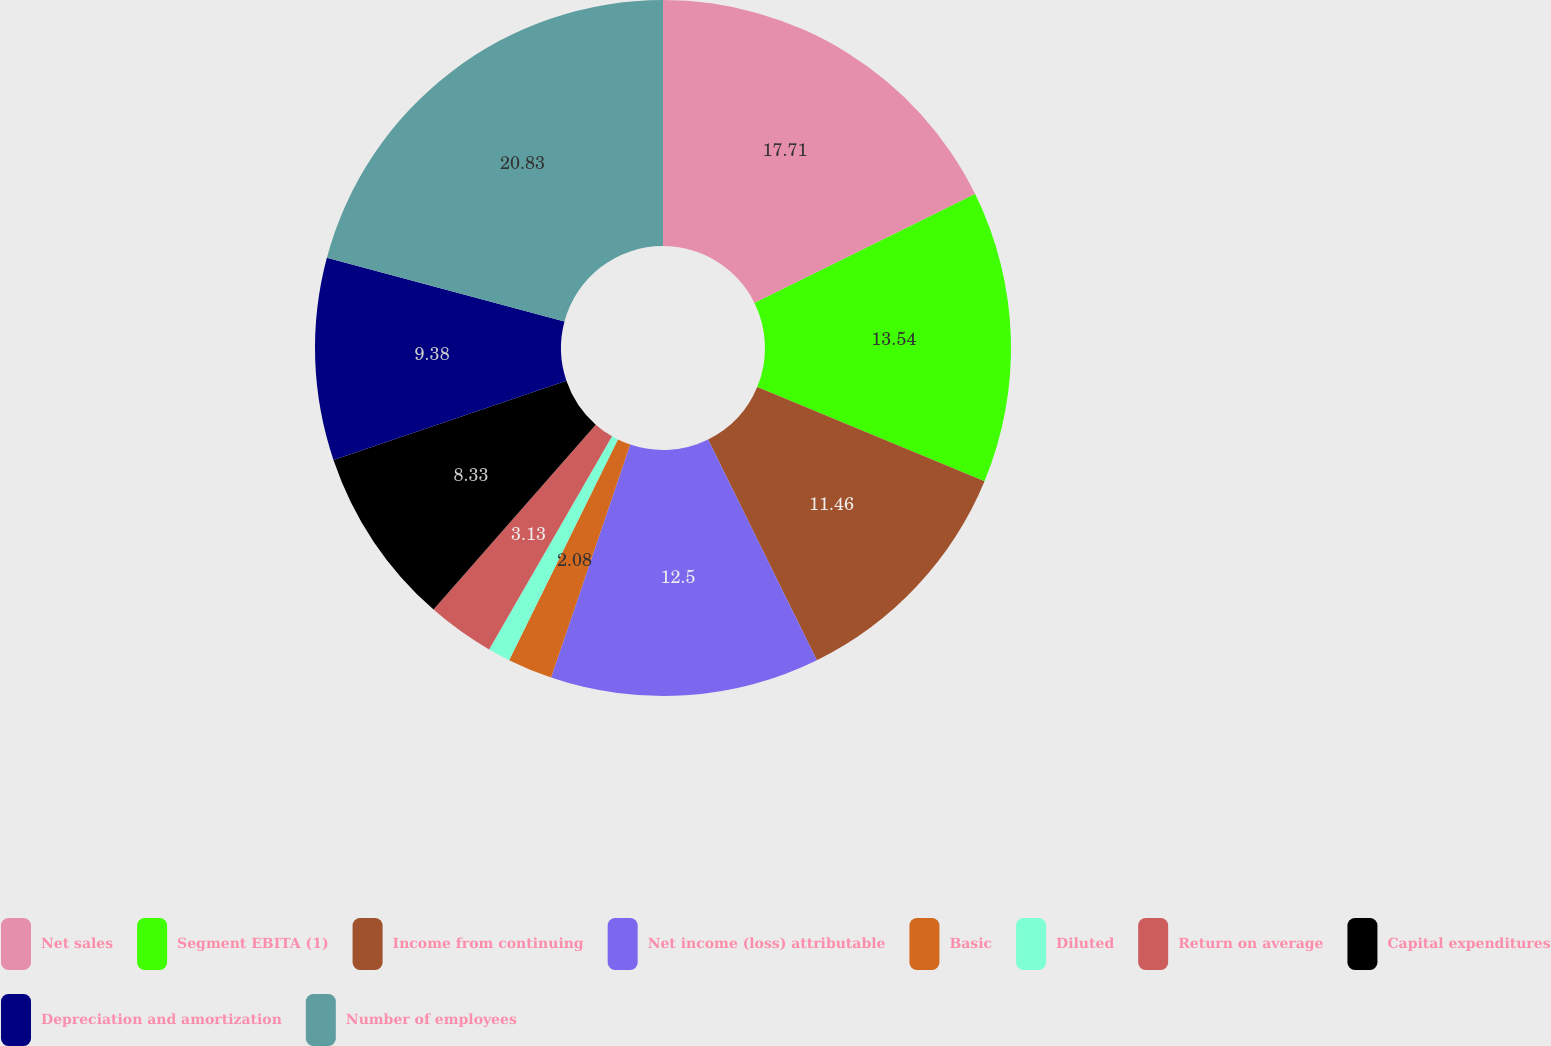Convert chart. <chart><loc_0><loc_0><loc_500><loc_500><pie_chart><fcel>Net sales<fcel>Segment EBITA (1)<fcel>Income from continuing<fcel>Net income (loss) attributable<fcel>Basic<fcel>Diluted<fcel>Return on average<fcel>Capital expenditures<fcel>Depreciation and amortization<fcel>Number of employees<nl><fcel>17.71%<fcel>13.54%<fcel>11.46%<fcel>12.5%<fcel>2.08%<fcel>1.04%<fcel>3.13%<fcel>8.33%<fcel>9.38%<fcel>20.83%<nl></chart> 